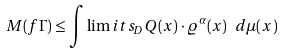<formula> <loc_0><loc_0><loc_500><loc_500>M ( f \Gamma ) \leq \int \lim i t s _ { D } Q ( x ) \cdot \varrho ^ { \alpha } ( x ) \ d \mu ( x )</formula> 